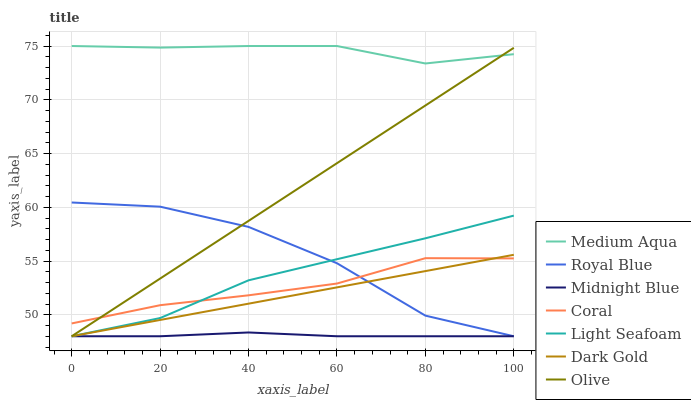Does Midnight Blue have the minimum area under the curve?
Answer yes or no. Yes. Does Medium Aqua have the maximum area under the curve?
Answer yes or no. Yes. Does Dark Gold have the minimum area under the curve?
Answer yes or no. No. Does Dark Gold have the maximum area under the curve?
Answer yes or no. No. Is Dark Gold the smoothest?
Answer yes or no. Yes. Is Royal Blue the roughest?
Answer yes or no. Yes. Is Coral the smoothest?
Answer yes or no. No. Is Coral the roughest?
Answer yes or no. No. Does Midnight Blue have the lowest value?
Answer yes or no. Yes. Does Coral have the lowest value?
Answer yes or no. No. Does Medium Aqua have the highest value?
Answer yes or no. Yes. Does Dark Gold have the highest value?
Answer yes or no. No. Is Royal Blue less than Medium Aqua?
Answer yes or no. Yes. Is Medium Aqua greater than Coral?
Answer yes or no. Yes. Does Olive intersect Royal Blue?
Answer yes or no. Yes. Is Olive less than Royal Blue?
Answer yes or no. No. Is Olive greater than Royal Blue?
Answer yes or no. No. Does Royal Blue intersect Medium Aqua?
Answer yes or no. No. 